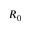<formula> <loc_0><loc_0><loc_500><loc_500>R _ { 0 }</formula> 